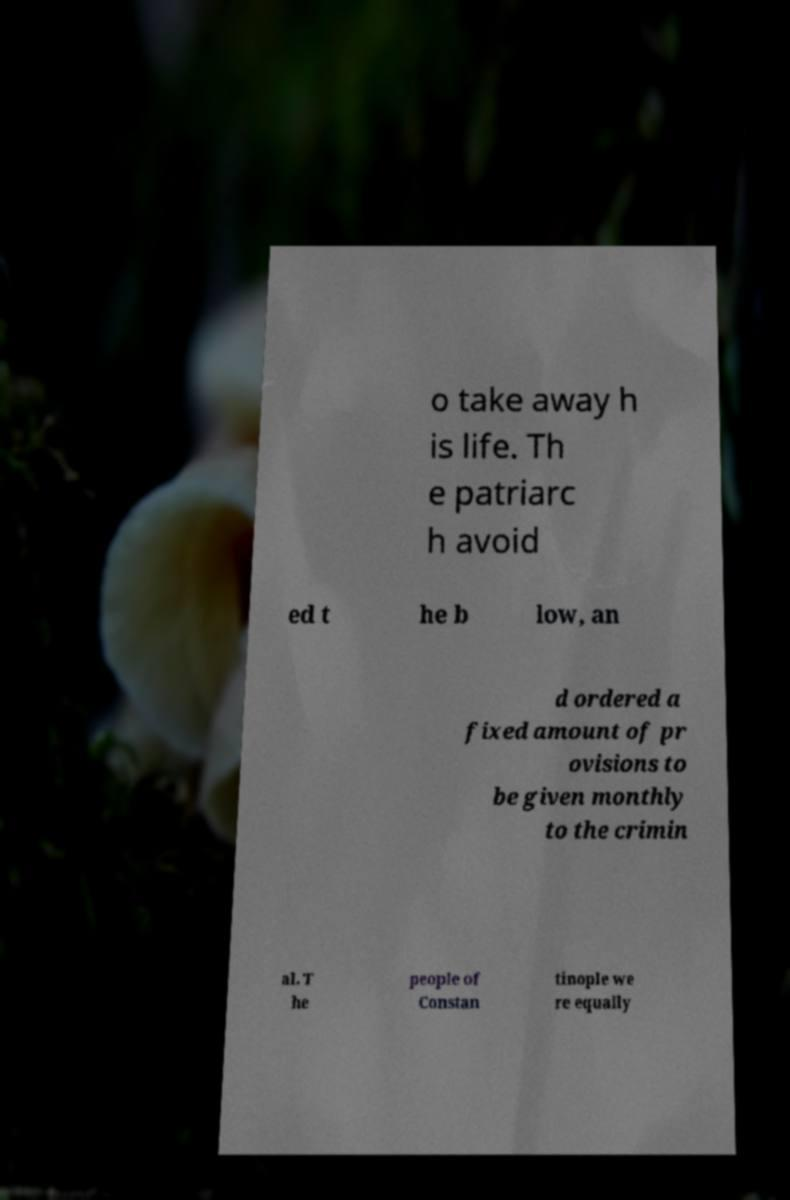What messages or text are displayed in this image? I need them in a readable, typed format. o take away h is life. Th e patriarc h avoid ed t he b low, an d ordered a fixed amount of pr ovisions to be given monthly to the crimin al. T he people of Constan tinople we re equally 